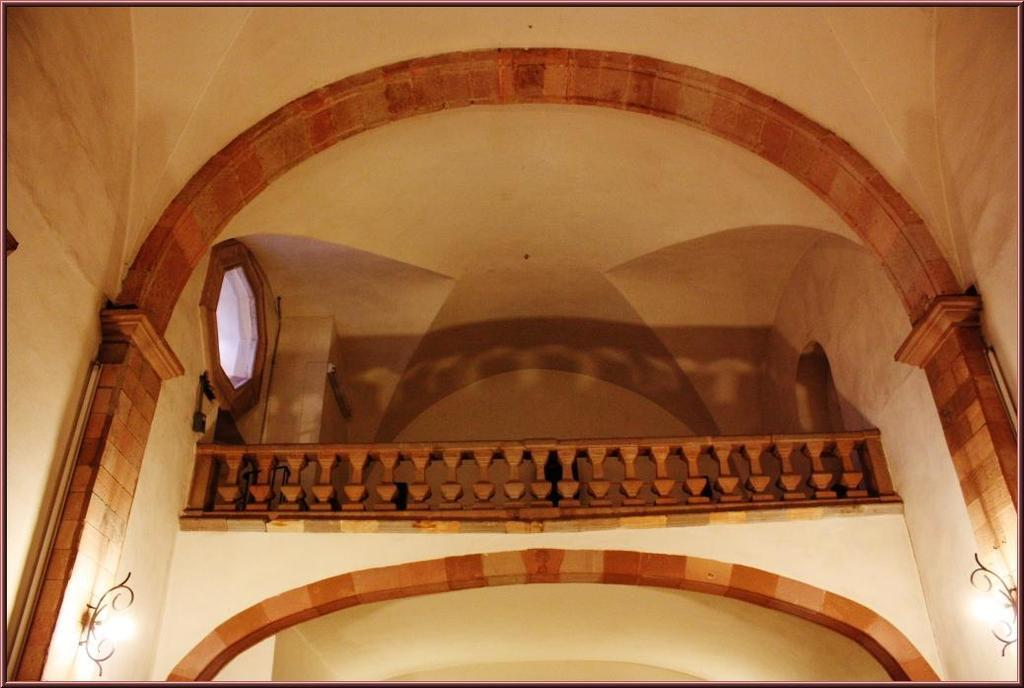What type of structure can be seen in the image? There is an arch in the image. What other feature is present in the image? There is a fence in the image. Are there any light sources visible in the image? Yes, there are lights in the image. Can you identify any openings in the image? There is a window in the image. Is there a beggar asking for money near the arch in the image? There is no beggar present in the image. What type of beef is being served at the event in the image? There is no event or beef present in the image. 